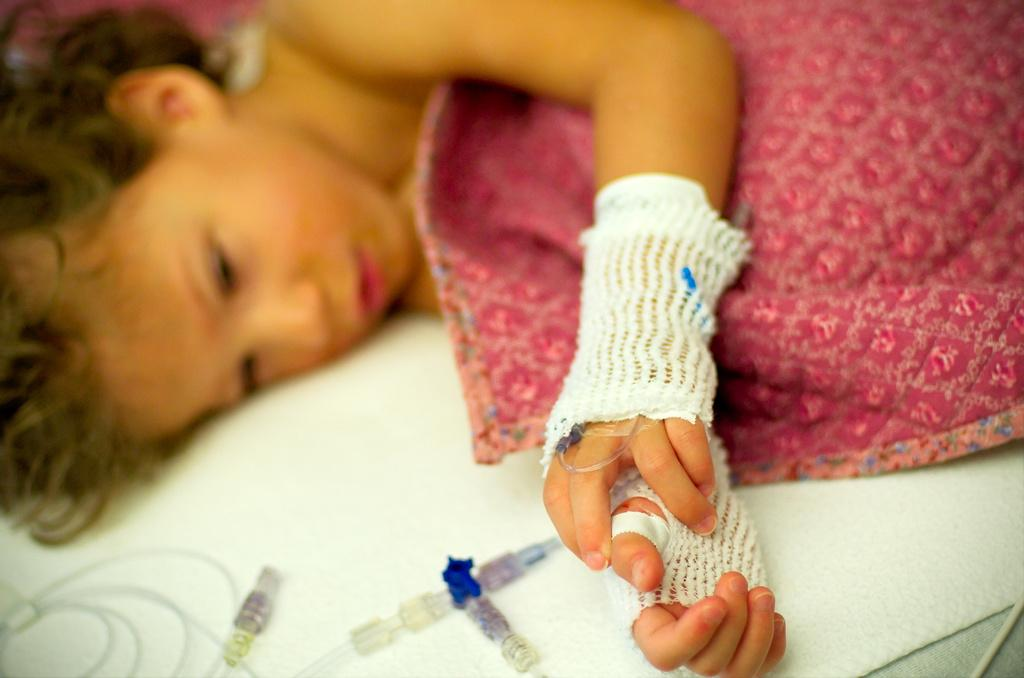What is the main subject of the image? There is a kid in the image. What is the kid doing in the image? The kid is lying on the bed. Can you describe the kid's appearance in the image? The kid has bandages on their hands. What else can be seen in the image? There is a blanket visible in the image, and there are syringes present. How does the kid expand the crack in the wall using the syringes in the image? There is no crack in the wall or any indication that the kid is using the syringes to expand it in the image. 